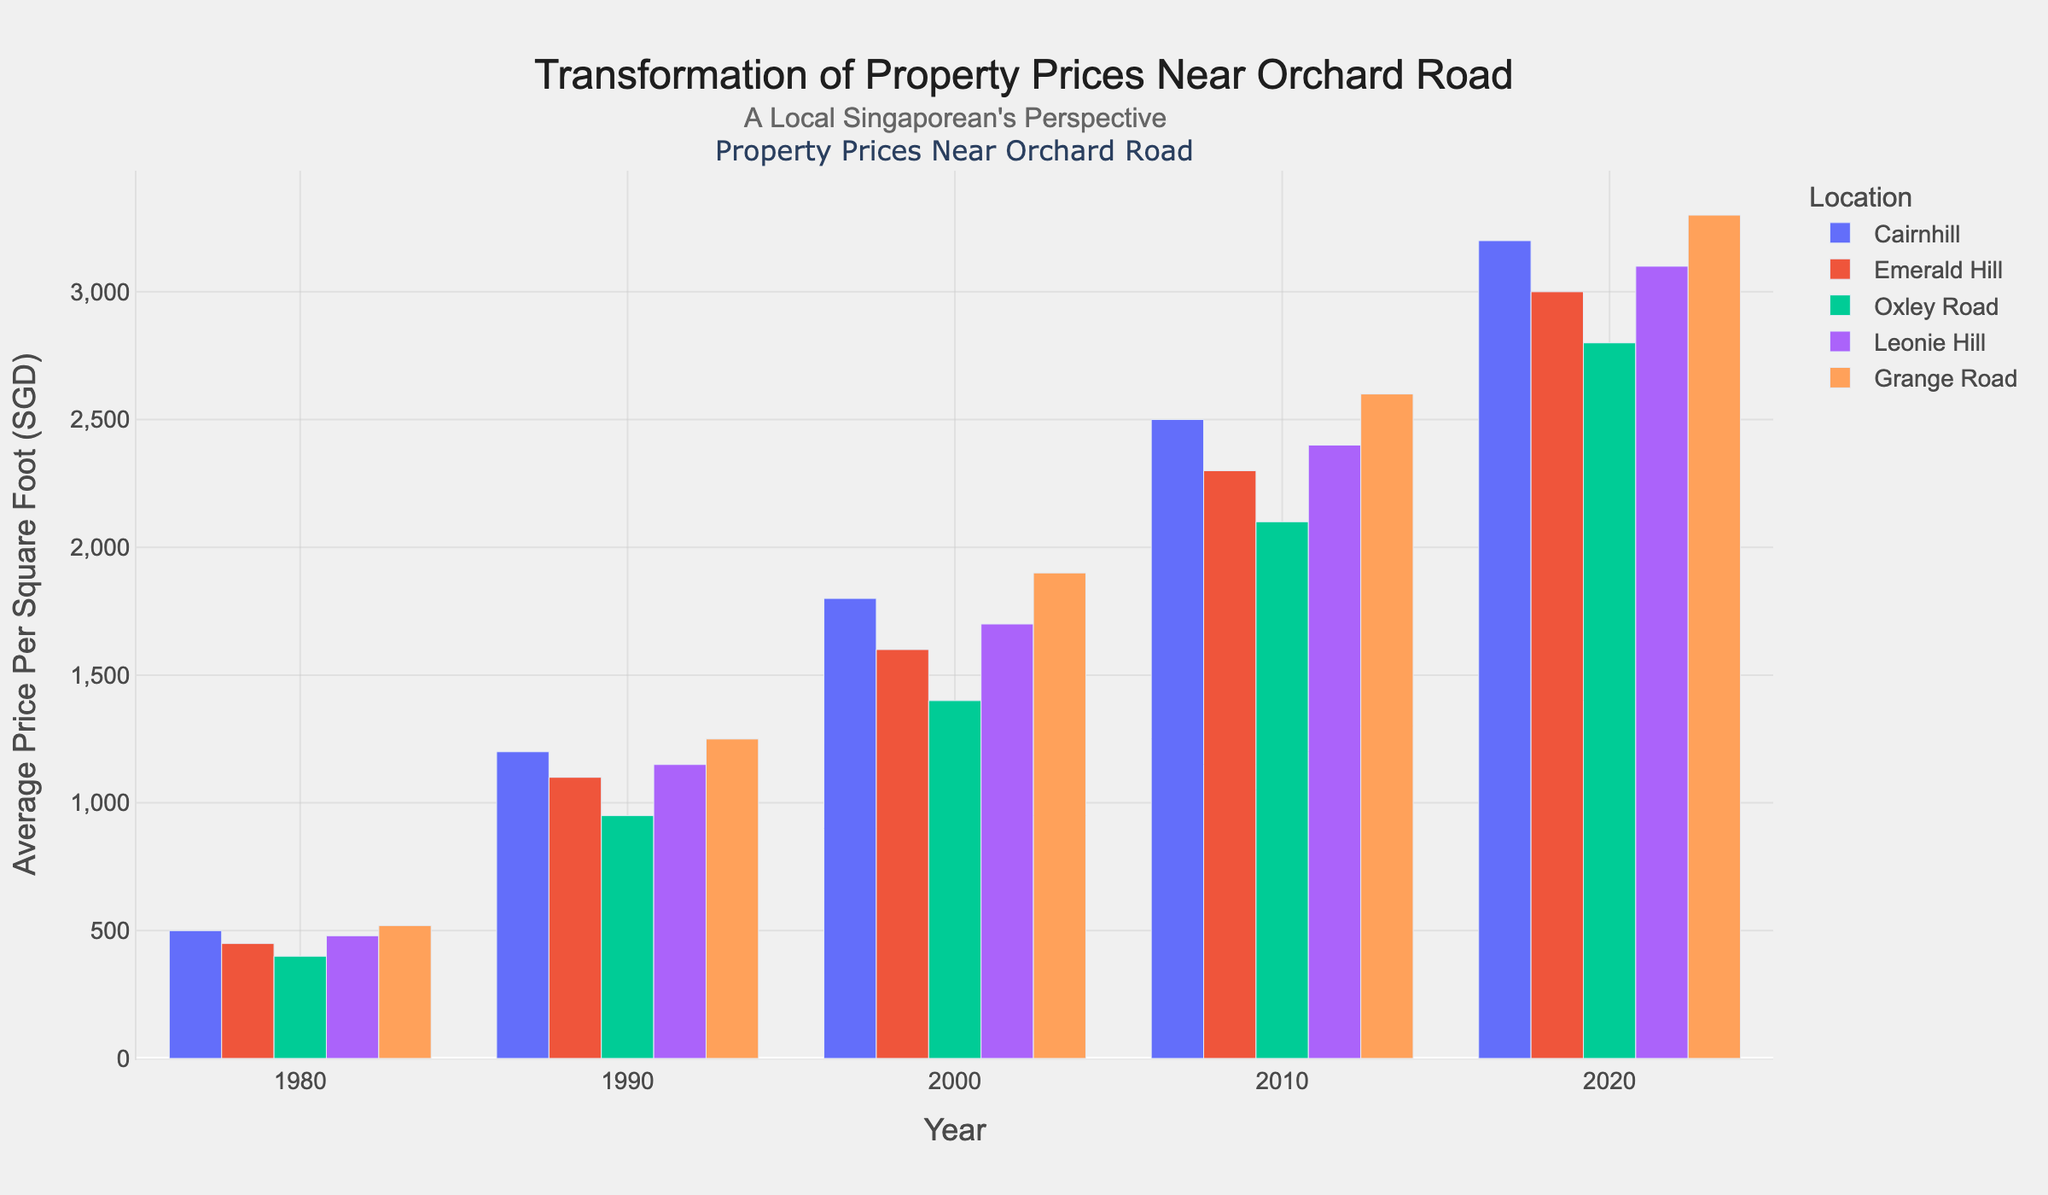What is the average price per square foot for Cairnhill in 2020? To find the average price per square foot for Cairnhill in 2020, simply look at the bar corresponding to Cairnhill in the year 2020, which is 3200 SGD.
Answer: 3200 SGD Which location had the highest average price per square foot in 1990? Compare the heights of the bars for all locations in the year 1990. Grange Road has the tallest bar at 1250 SGD.
Answer: Grange Road By how much did the average price per square foot for Emerald Hill increase from 1980 to 2020? In 1980, the price was 450 SGD, and in 2020, it was 3000 SGD. The increase is 3000 - 450 = 2550 SGD.
Answer: 2550 SGD Which location had the lowest average price per square foot in 1980? Compare the heights of the bars for all locations in the year 1980. Oxley Road had the shortest bar at 400 SGD.
Answer: Oxley Road What is the combined average price per square foot in 2000 for Cairnhill and Leonie Hill? Add the average prices for Cairnhill (1800 SGD) and Leonie Hill (1700 SGD). The sum is 1800 + 1700 = 3500 SGD.
Answer: 3500 SGD Which decade saw the largest increase in average price per square foot for Grange Road? Calculate the increase for each decade: 
1980-1990: 1250 - 520 = 730 
1990-2000: 1900 - 1250 = 650 
2000-2010: 2600 - 1900 = 700 
2010-2020: 3300 - 2600 = 700. 
The largest increase was from 1980-1990 at 730 SGD.
Answer: 1980-1990 Between Cairnhill and Oxley Road, which one had a greater percentage increase in average price per square foot from 1980 to 2020? Calculate the percentage increase for each:
Cairnhill: ((3200 - 500) / 500) * 100 = 540%
Oxley Road: ((2800 - 400) / 400) * 100 = 600%. 
Oxley Road had a greater percentage increase.
Answer: Oxley Road How much more expensive was the average price per square foot for Leonie Hill compared to Oxley Road in 2010? Subtract Oxley Road's price (2100 SGD) from Leonie Hill's price (2400 SGD). The difference is 2400 - 2100 = 300 SGD.
Answer: 300 SGD What is the general trend of average property prices near Orchard Road from 1980 to 2020? Observing the bars from 1980 to 2020, all locations show an overall upward trend in property prices per square foot.
Answer: Upward trend 